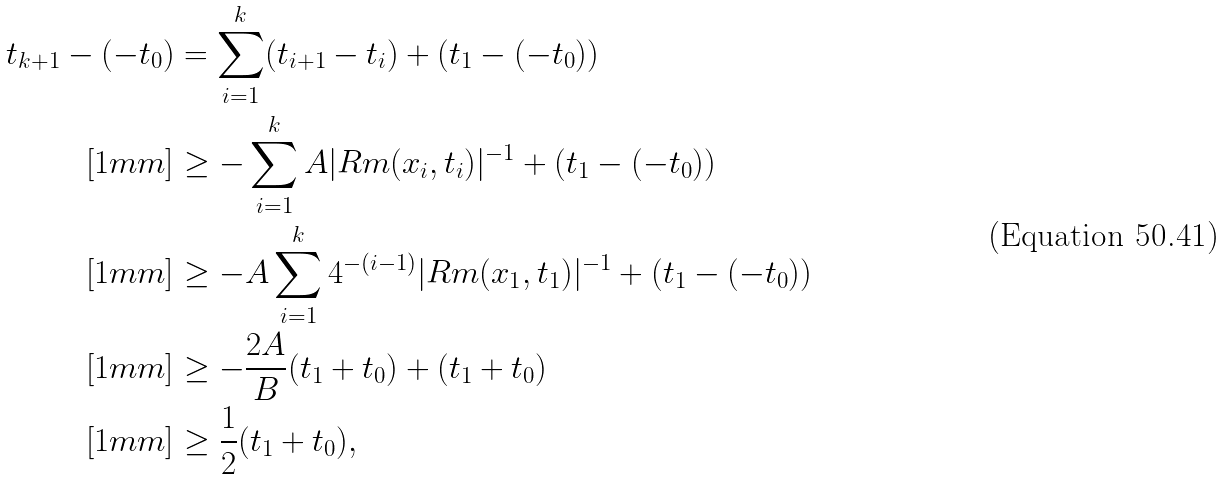<formula> <loc_0><loc_0><loc_500><loc_500>t _ { k + 1 } - ( - t _ { 0 } ) & = \sum _ { i = 1 } ^ { k } ( t _ { i + 1 } - t _ { i } ) + ( t _ { 1 } - ( - t _ { 0 } ) ) \\ [ 1 m m ] & \geq - \sum _ { i = 1 } ^ { k } A | R m ( x _ { i } , t _ { i } ) | ^ { - 1 } + ( t _ { 1 } - ( - t _ { 0 } ) ) \\ [ 1 m m ] & \geq - A \sum _ { i = 1 } ^ { k } 4 ^ { - ( i - 1 ) } | R m ( x _ { 1 } , t _ { 1 } ) | ^ { - 1 } + ( t _ { 1 } - ( - t _ { 0 } ) ) \\ [ 1 m m ] & \geq - \frac { 2 A } { B } ( t _ { 1 } + t _ { 0 } ) + ( t _ { 1 } + t _ { 0 } ) \\ [ 1 m m ] & \geq \frac { 1 } { 2 } ( t _ { 1 } + t _ { 0 } ) ,</formula> 